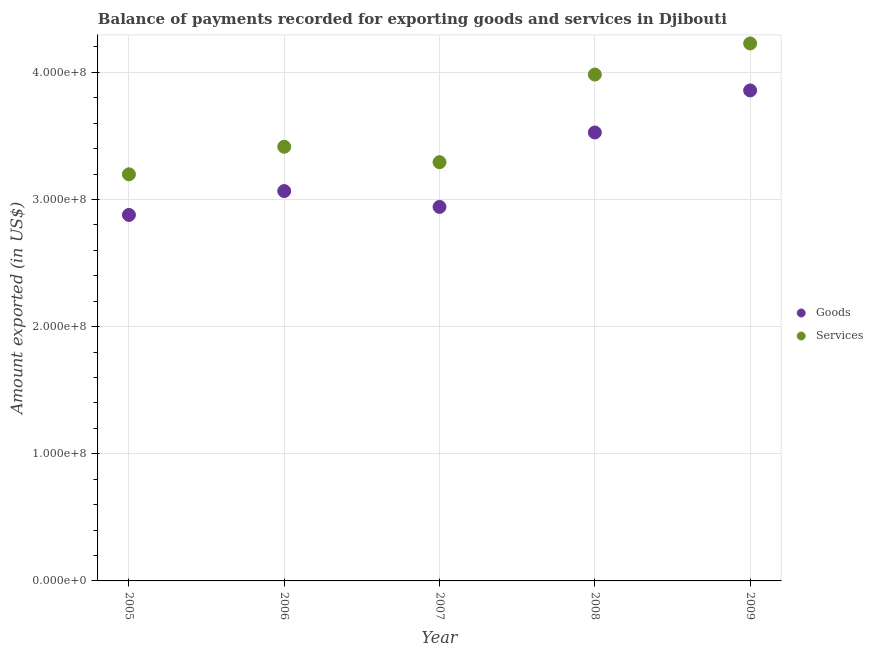Is the number of dotlines equal to the number of legend labels?
Your answer should be compact. Yes. What is the amount of services exported in 2008?
Your response must be concise. 3.98e+08. Across all years, what is the maximum amount of services exported?
Ensure brevity in your answer.  4.23e+08. Across all years, what is the minimum amount of goods exported?
Your answer should be compact. 2.88e+08. What is the total amount of services exported in the graph?
Keep it short and to the point. 1.81e+09. What is the difference between the amount of services exported in 2005 and that in 2007?
Keep it short and to the point. -9.54e+06. What is the difference between the amount of goods exported in 2006 and the amount of services exported in 2005?
Provide a short and direct response. -1.32e+07. What is the average amount of services exported per year?
Make the answer very short. 3.62e+08. In the year 2007, what is the difference between the amount of services exported and amount of goods exported?
Provide a succinct answer. 3.52e+07. What is the ratio of the amount of goods exported in 2008 to that in 2009?
Your answer should be compact. 0.91. Is the amount of goods exported in 2005 less than that in 2009?
Make the answer very short. Yes. Is the difference between the amount of goods exported in 2006 and 2008 greater than the difference between the amount of services exported in 2006 and 2008?
Your answer should be very brief. Yes. What is the difference between the highest and the second highest amount of services exported?
Your response must be concise. 2.45e+07. What is the difference between the highest and the lowest amount of services exported?
Give a very brief answer. 1.03e+08. In how many years, is the amount of goods exported greater than the average amount of goods exported taken over all years?
Your response must be concise. 2. Is the amount of services exported strictly greater than the amount of goods exported over the years?
Offer a very short reply. Yes. Is the amount of goods exported strictly less than the amount of services exported over the years?
Make the answer very short. Yes. Does the graph contain any zero values?
Keep it short and to the point. No. Where does the legend appear in the graph?
Give a very brief answer. Center right. How are the legend labels stacked?
Provide a short and direct response. Vertical. What is the title of the graph?
Give a very brief answer. Balance of payments recorded for exporting goods and services in Djibouti. What is the label or title of the X-axis?
Your response must be concise. Year. What is the label or title of the Y-axis?
Give a very brief answer. Amount exported (in US$). What is the Amount exported (in US$) in Goods in 2005?
Ensure brevity in your answer.  2.88e+08. What is the Amount exported (in US$) of Services in 2005?
Your answer should be compact. 3.20e+08. What is the Amount exported (in US$) of Goods in 2006?
Offer a very short reply. 3.07e+08. What is the Amount exported (in US$) in Services in 2006?
Make the answer very short. 3.41e+08. What is the Amount exported (in US$) of Goods in 2007?
Keep it short and to the point. 2.94e+08. What is the Amount exported (in US$) in Services in 2007?
Ensure brevity in your answer.  3.29e+08. What is the Amount exported (in US$) of Goods in 2008?
Offer a very short reply. 3.53e+08. What is the Amount exported (in US$) of Services in 2008?
Your answer should be compact. 3.98e+08. What is the Amount exported (in US$) in Goods in 2009?
Your answer should be very brief. 3.86e+08. What is the Amount exported (in US$) of Services in 2009?
Offer a terse response. 4.23e+08. Across all years, what is the maximum Amount exported (in US$) in Goods?
Provide a short and direct response. 3.86e+08. Across all years, what is the maximum Amount exported (in US$) in Services?
Your answer should be compact. 4.23e+08. Across all years, what is the minimum Amount exported (in US$) in Goods?
Your answer should be very brief. 2.88e+08. Across all years, what is the minimum Amount exported (in US$) of Services?
Offer a very short reply. 3.20e+08. What is the total Amount exported (in US$) of Goods in the graph?
Your response must be concise. 1.63e+09. What is the total Amount exported (in US$) in Services in the graph?
Your answer should be compact. 1.81e+09. What is the difference between the Amount exported (in US$) in Goods in 2005 and that in 2006?
Offer a terse response. -1.88e+07. What is the difference between the Amount exported (in US$) of Services in 2005 and that in 2006?
Make the answer very short. -2.17e+07. What is the difference between the Amount exported (in US$) of Goods in 2005 and that in 2007?
Your answer should be compact. -6.30e+06. What is the difference between the Amount exported (in US$) in Services in 2005 and that in 2007?
Your response must be concise. -9.54e+06. What is the difference between the Amount exported (in US$) in Goods in 2005 and that in 2008?
Give a very brief answer. -6.48e+07. What is the difference between the Amount exported (in US$) in Services in 2005 and that in 2008?
Give a very brief answer. -7.85e+07. What is the difference between the Amount exported (in US$) of Goods in 2005 and that in 2009?
Give a very brief answer. -9.79e+07. What is the difference between the Amount exported (in US$) in Services in 2005 and that in 2009?
Provide a short and direct response. -1.03e+08. What is the difference between the Amount exported (in US$) in Goods in 2006 and that in 2007?
Offer a very short reply. 1.25e+07. What is the difference between the Amount exported (in US$) in Services in 2006 and that in 2007?
Your response must be concise. 1.21e+07. What is the difference between the Amount exported (in US$) in Goods in 2006 and that in 2008?
Offer a very short reply. -4.61e+07. What is the difference between the Amount exported (in US$) of Services in 2006 and that in 2008?
Your answer should be compact. -5.68e+07. What is the difference between the Amount exported (in US$) in Goods in 2006 and that in 2009?
Offer a very short reply. -7.92e+07. What is the difference between the Amount exported (in US$) in Services in 2006 and that in 2009?
Keep it short and to the point. -8.13e+07. What is the difference between the Amount exported (in US$) in Goods in 2007 and that in 2008?
Offer a very short reply. -5.85e+07. What is the difference between the Amount exported (in US$) of Services in 2007 and that in 2008?
Your answer should be compact. -6.89e+07. What is the difference between the Amount exported (in US$) of Goods in 2007 and that in 2009?
Give a very brief answer. -9.16e+07. What is the difference between the Amount exported (in US$) in Services in 2007 and that in 2009?
Provide a succinct answer. -9.34e+07. What is the difference between the Amount exported (in US$) in Goods in 2008 and that in 2009?
Provide a short and direct response. -3.31e+07. What is the difference between the Amount exported (in US$) of Services in 2008 and that in 2009?
Your answer should be compact. -2.45e+07. What is the difference between the Amount exported (in US$) of Goods in 2005 and the Amount exported (in US$) of Services in 2006?
Give a very brief answer. -5.36e+07. What is the difference between the Amount exported (in US$) of Goods in 2005 and the Amount exported (in US$) of Services in 2007?
Provide a succinct answer. -4.15e+07. What is the difference between the Amount exported (in US$) in Goods in 2005 and the Amount exported (in US$) in Services in 2008?
Give a very brief answer. -1.10e+08. What is the difference between the Amount exported (in US$) in Goods in 2005 and the Amount exported (in US$) in Services in 2009?
Give a very brief answer. -1.35e+08. What is the difference between the Amount exported (in US$) of Goods in 2006 and the Amount exported (in US$) of Services in 2007?
Your response must be concise. -2.27e+07. What is the difference between the Amount exported (in US$) of Goods in 2006 and the Amount exported (in US$) of Services in 2008?
Your answer should be very brief. -9.17e+07. What is the difference between the Amount exported (in US$) in Goods in 2006 and the Amount exported (in US$) in Services in 2009?
Make the answer very short. -1.16e+08. What is the difference between the Amount exported (in US$) of Goods in 2007 and the Amount exported (in US$) of Services in 2008?
Offer a very short reply. -1.04e+08. What is the difference between the Amount exported (in US$) in Goods in 2007 and the Amount exported (in US$) in Services in 2009?
Give a very brief answer. -1.29e+08. What is the difference between the Amount exported (in US$) in Goods in 2008 and the Amount exported (in US$) in Services in 2009?
Provide a succinct answer. -7.00e+07. What is the average Amount exported (in US$) in Goods per year?
Ensure brevity in your answer.  3.25e+08. What is the average Amount exported (in US$) in Services per year?
Your answer should be very brief. 3.62e+08. In the year 2005, what is the difference between the Amount exported (in US$) of Goods and Amount exported (in US$) of Services?
Keep it short and to the point. -3.20e+07. In the year 2006, what is the difference between the Amount exported (in US$) of Goods and Amount exported (in US$) of Services?
Provide a short and direct response. -3.49e+07. In the year 2007, what is the difference between the Amount exported (in US$) in Goods and Amount exported (in US$) in Services?
Provide a succinct answer. -3.52e+07. In the year 2008, what is the difference between the Amount exported (in US$) of Goods and Amount exported (in US$) of Services?
Keep it short and to the point. -4.56e+07. In the year 2009, what is the difference between the Amount exported (in US$) of Goods and Amount exported (in US$) of Services?
Offer a very short reply. -3.70e+07. What is the ratio of the Amount exported (in US$) of Goods in 2005 to that in 2006?
Provide a short and direct response. 0.94. What is the ratio of the Amount exported (in US$) of Services in 2005 to that in 2006?
Provide a short and direct response. 0.94. What is the ratio of the Amount exported (in US$) in Goods in 2005 to that in 2007?
Make the answer very short. 0.98. What is the ratio of the Amount exported (in US$) in Services in 2005 to that in 2007?
Keep it short and to the point. 0.97. What is the ratio of the Amount exported (in US$) of Goods in 2005 to that in 2008?
Your answer should be compact. 0.82. What is the ratio of the Amount exported (in US$) in Services in 2005 to that in 2008?
Your answer should be very brief. 0.8. What is the ratio of the Amount exported (in US$) in Goods in 2005 to that in 2009?
Ensure brevity in your answer.  0.75. What is the ratio of the Amount exported (in US$) of Services in 2005 to that in 2009?
Provide a short and direct response. 0.76. What is the ratio of the Amount exported (in US$) of Goods in 2006 to that in 2007?
Keep it short and to the point. 1.04. What is the ratio of the Amount exported (in US$) in Services in 2006 to that in 2007?
Offer a very short reply. 1.04. What is the ratio of the Amount exported (in US$) in Goods in 2006 to that in 2008?
Offer a terse response. 0.87. What is the ratio of the Amount exported (in US$) of Services in 2006 to that in 2008?
Ensure brevity in your answer.  0.86. What is the ratio of the Amount exported (in US$) of Goods in 2006 to that in 2009?
Your answer should be compact. 0.79. What is the ratio of the Amount exported (in US$) in Services in 2006 to that in 2009?
Keep it short and to the point. 0.81. What is the ratio of the Amount exported (in US$) of Goods in 2007 to that in 2008?
Provide a succinct answer. 0.83. What is the ratio of the Amount exported (in US$) in Services in 2007 to that in 2008?
Give a very brief answer. 0.83. What is the ratio of the Amount exported (in US$) of Goods in 2007 to that in 2009?
Offer a very short reply. 0.76. What is the ratio of the Amount exported (in US$) in Services in 2007 to that in 2009?
Offer a very short reply. 0.78. What is the ratio of the Amount exported (in US$) in Goods in 2008 to that in 2009?
Keep it short and to the point. 0.91. What is the ratio of the Amount exported (in US$) in Services in 2008 to that in 2009?
Your answer should be compact. 0.94. What is the difference between the highest and the second highest Amount exported (in US$) of Goods?
Offer a very short reply. 3.31e+07. What is the difference between the highest and the second highest Amount exported (in US$) of Services?
Your response must be concise. 2.45e+07. What is the difference between the highest and the lowest Amount exported (in US$) in Goods?
Provide a short and direct response. 9.79e+07. What is the difference between the highest and the lowest Amount exported (in US$) in Services?
Your answer should be very brief. 1.03e+08. 